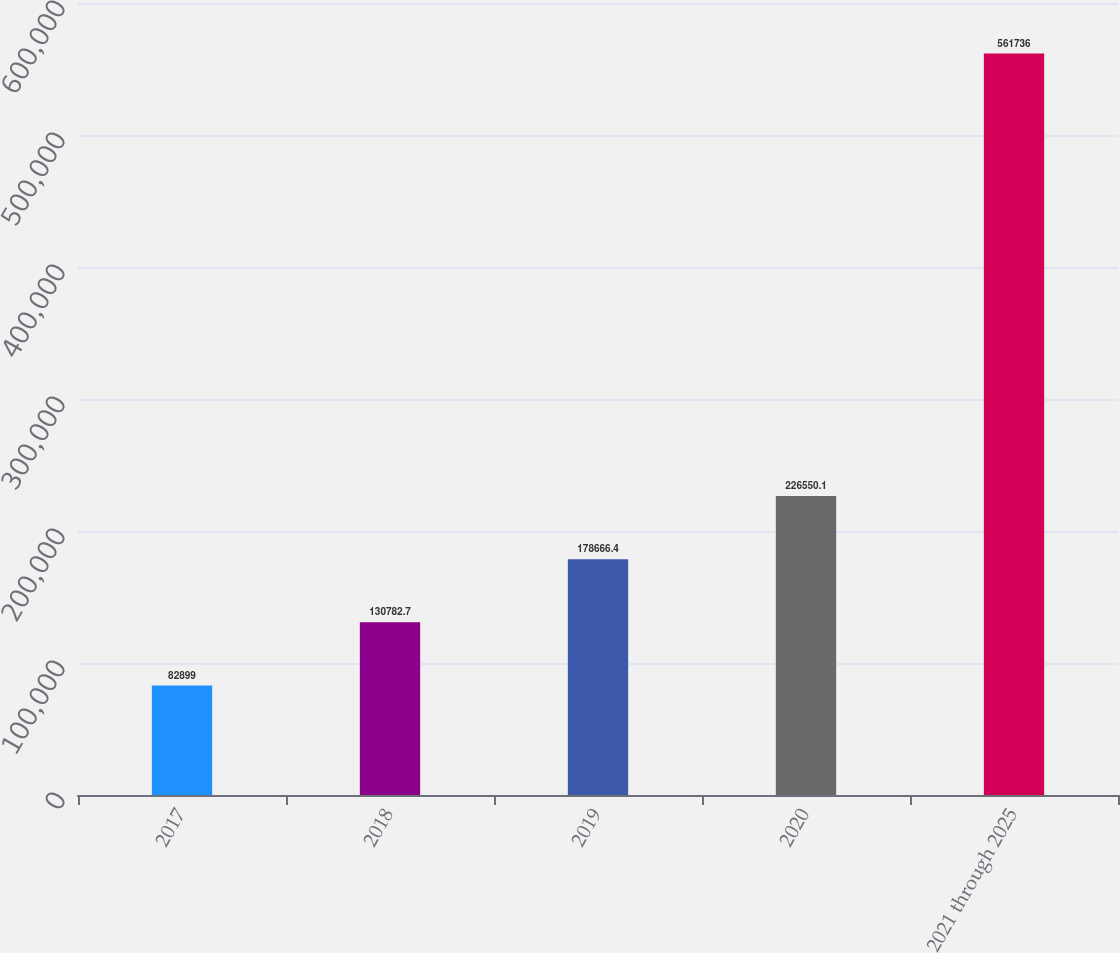Convert chart to OTSL. <chart><loc_0><loc_0><loc_500><loc_500><bar_chart><fcel>2017<fcel>2018<fcel>2019<fcel>2020<fcel>2021 through 2025<nl><fcel>82899<fcel>130783<fcel>178666<fcel>226550<fcel>561736<nl></chart> 